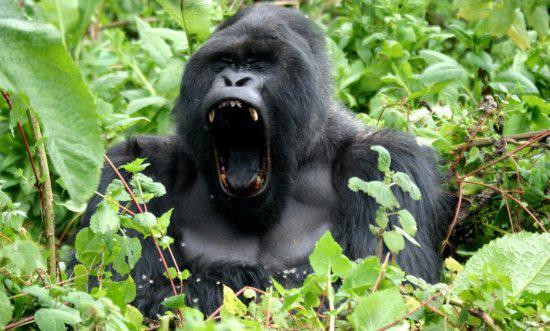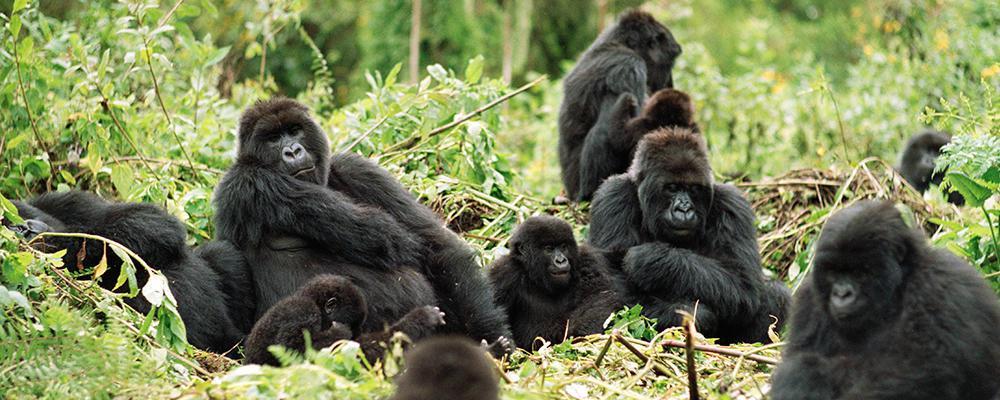The first image is the image on the left, the second image is the image on the right. Considering the images on both sides, is "There are exactly two gorillas in total." valid? Answer yes or no. No. The first image is the image on the left, the second image is the image on the right. Assess this claim about the two images: "There are no more than two apes in total.". Correct or not? Answer yes or no. No. 